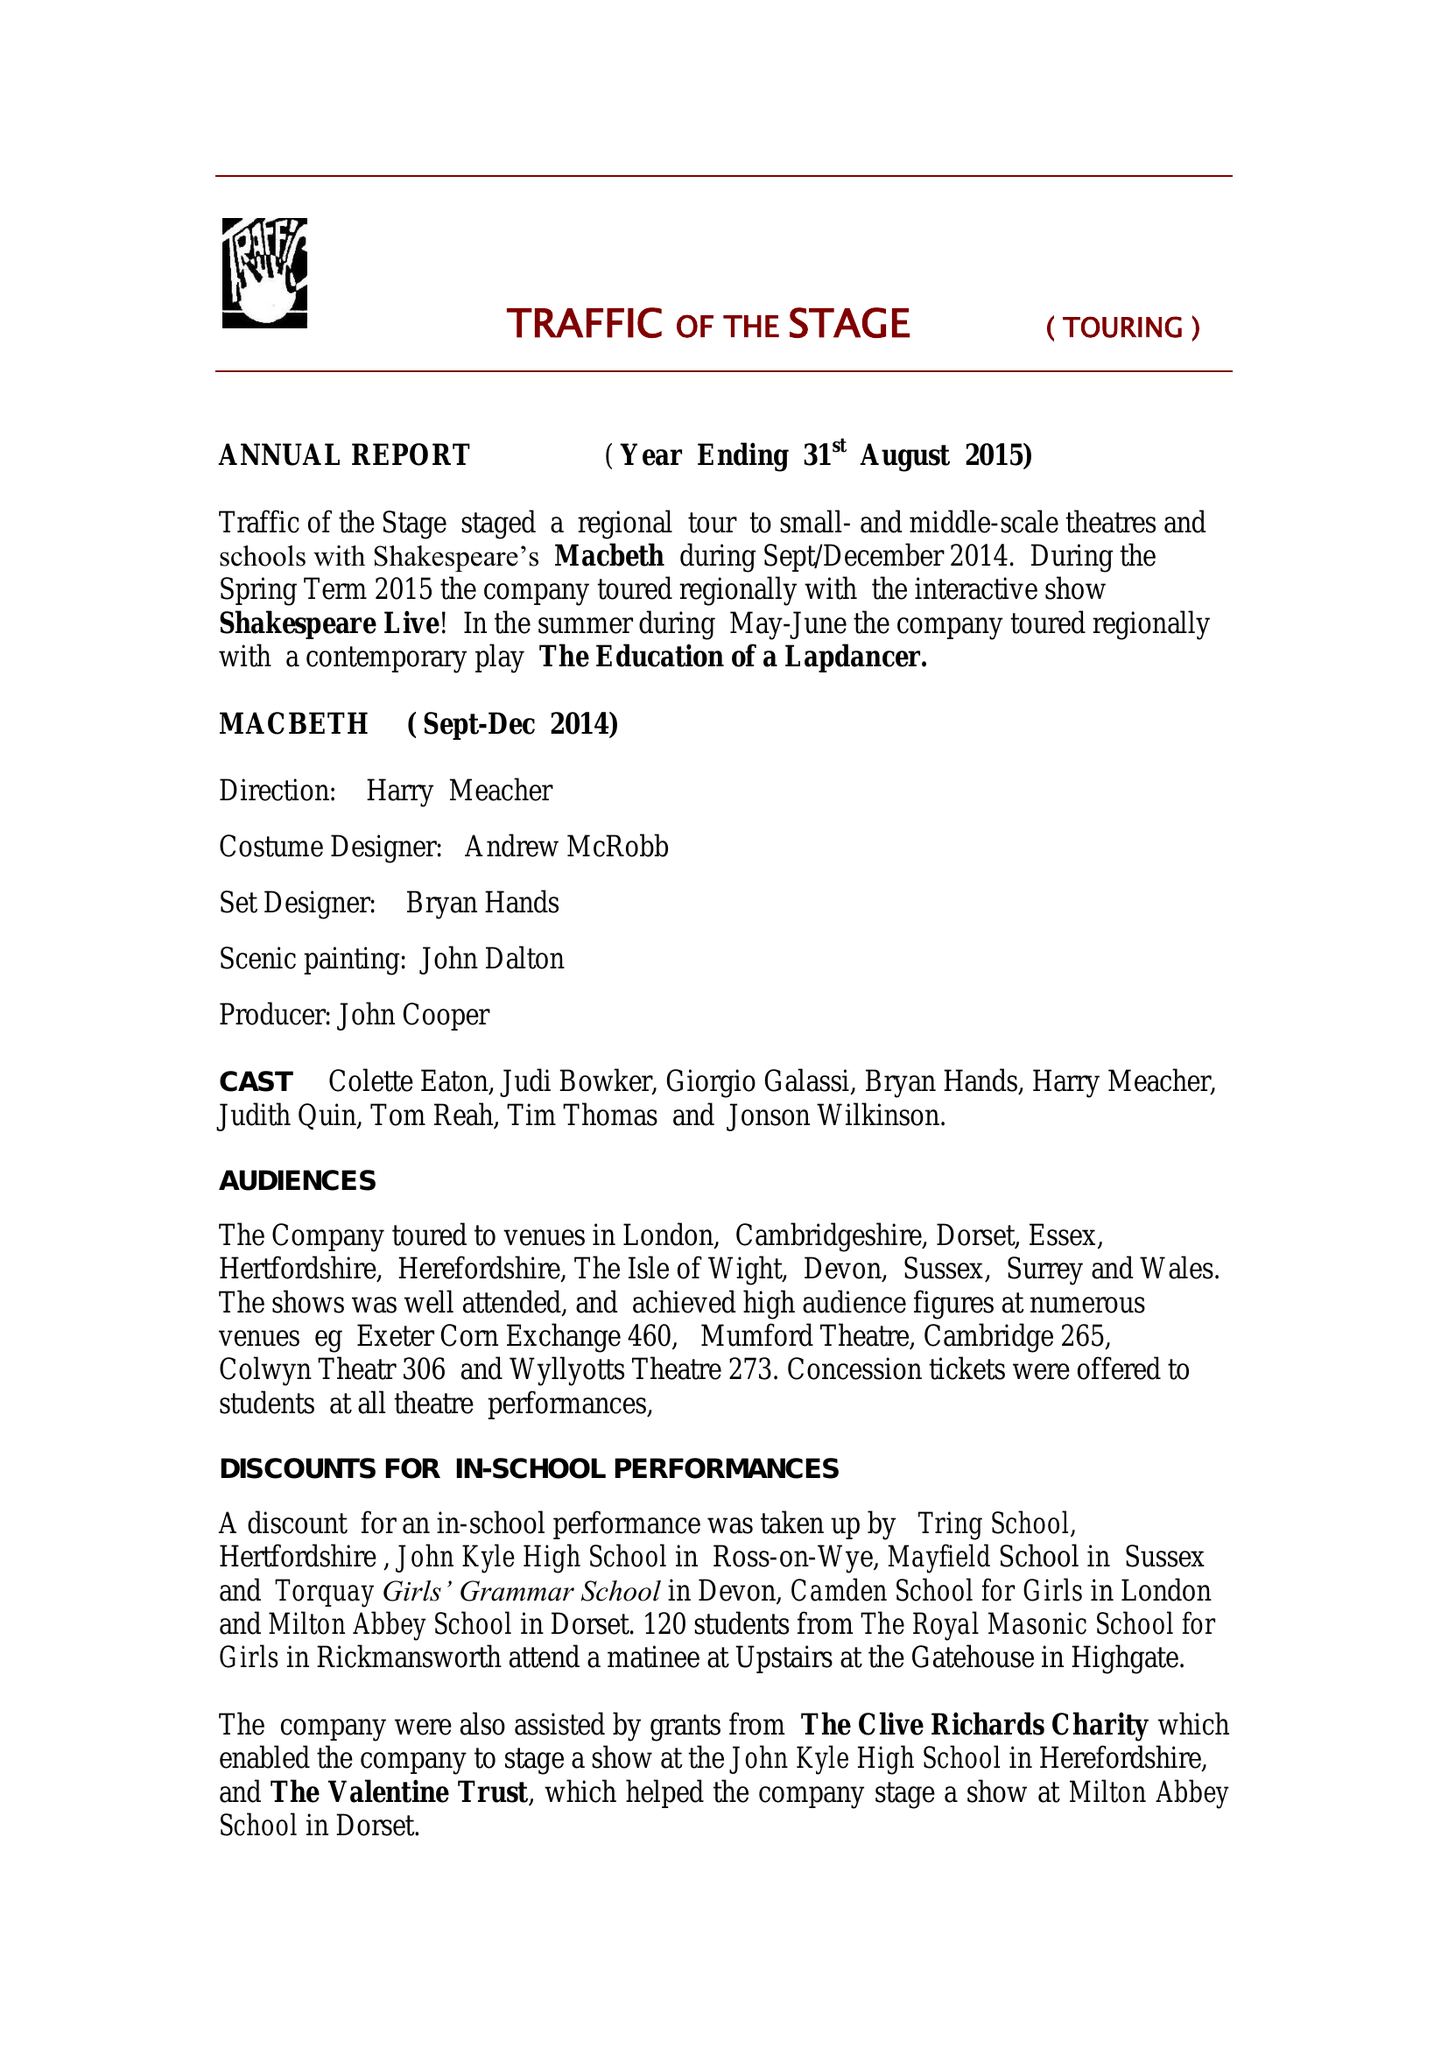What is the value for the spending_annually_in_british_pounds?
Answer the question using a single word or phrase. 48544.25 